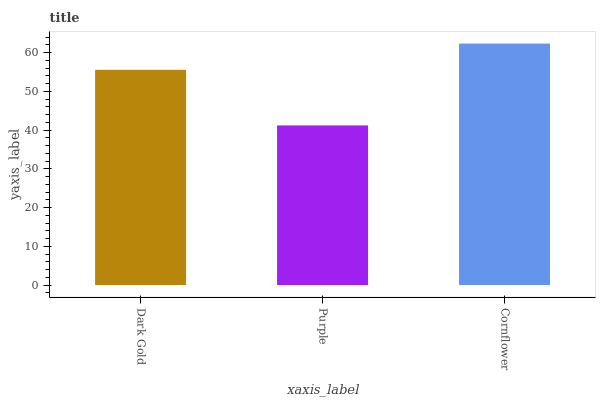Is Purple the minimum?
Answer yes or no. Yes. Is Cornflower the maximum?
Answer yes or no. Yes. Is Cornflower the minimum?
Answer yes or no. No. Is Purple the maximum?
Answer yes or no. No. Is Cornflower greater than Purple?
Answer yes or no. Yes. Is Purple less than Cornflower?
Answer yes or no. Yes. Is Purple greater than Cornflower?
Answer yes or no. No. Is Cornflower less than Purple?
Answer yes or no. No. Is Dark Gold the high median?
Answer yes or no. Yes. Is Dark Gold the low median?
Answer yes or no. Yes. Is Purple the high median?
Answer yes or no. No. Is Purple the low median?
Answer yes or no. No. 